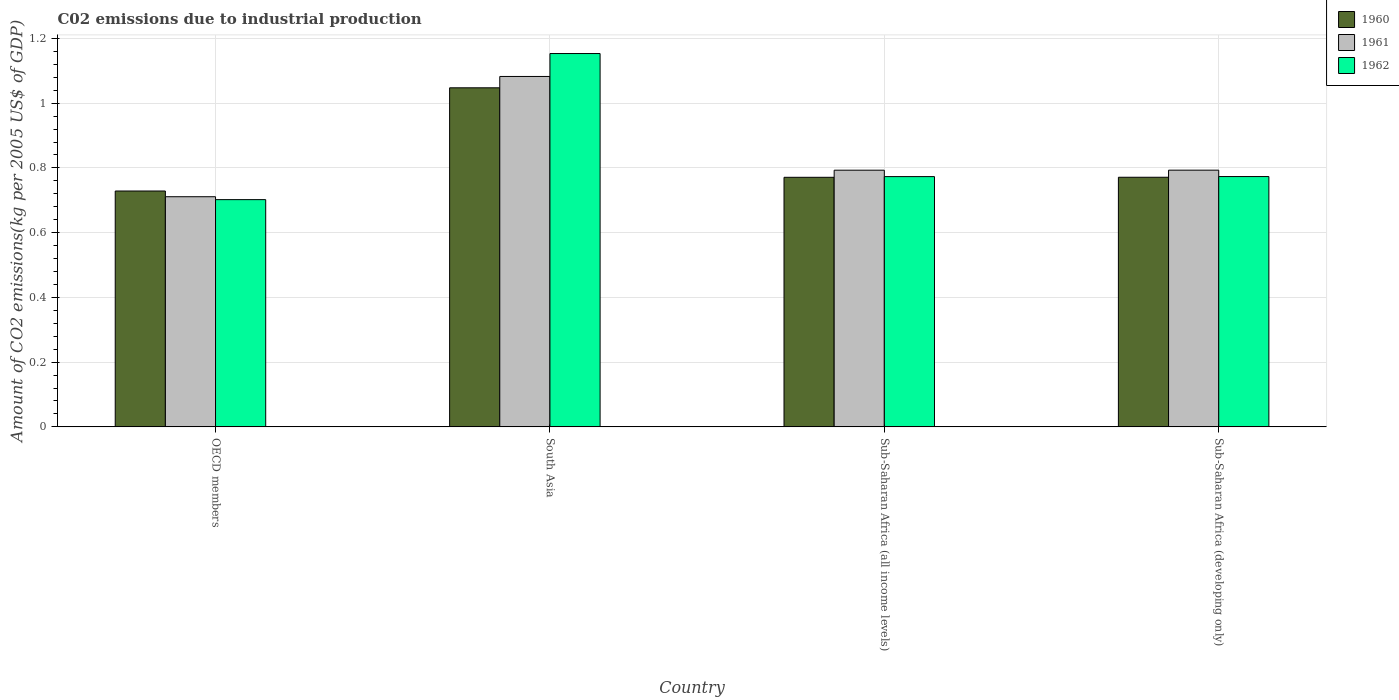How many groups of bars are there?
Your answer should be very brief. 4. Are the number of bars per tick equal to the number of legend labels?
Keep it short and to the point. Yes. How many bars are there on the 2nd tick from the left?
Ensure brevity in your answer.  3. In how many cases, is the number of bars for a given country not equal to the number of legend labels?
Ensure brevity in your answer.  0. What is the amount of CO2 emitted due to industrial production in 1962 in South Asia?
Offer a very short reply. 1.15. Across all countries, what is the maximum amount of CO2 emitted due to industrial production in 1961?
Keep it short and to the point. 1.08. Across all countries, what is the minimum amount of CO2 emitted due to industrial production in 1960?
Ensure brevity in your answer.  0.73. In which country was the amount of CO2 emitted due to industrial production in 1961 maximum?
Give a very brief answer. South Asia. In which country was the amount of CO2 emitted due to industrial production in 1962 minimum?
Offer a terse response. OECD members. What is the total amount of CO2 emitted due to industrial production in 1962 in the graph?
Provide a succinct answer. 3.4. What is the difference between the amount of CO2 emitted due to industrial production in 1961 in OECD members and that in Sub-Saharan Africa (developing only)?
Your answer should be compact. -0.08. What is the difference between the amount of CO2 emitted due to industrial production in 1961 in South Asia and the amount of CO2 emitted due to industrial production in 1962 in Sub-Saharan Africa (developing only)?
Your response must be concise. 0.31. What is the average amount of CO2 emitted due to industrial production in 1961 per country?
Your answer should be compact. 0.84. What is the difference between the amount of CO2 emitted due to industrial production of/in 1961 and amount of CO2 emitted due to industrial production of/in 1960 in South Asia?
Give a very brief answer. 0.04. In how many countries, is the amount of CO2 emitted due to industrial production in 1960 greater than 0.24000000000000002 kg?
Ensure brevity in your answer.  4. What is the ratio of the amount of CO2 emitted due to industrial production in 1960 in South Asia to that in Sub-Saharan Africa (developing only)?
Make the answer very short. 1.36. What is the difference between the highest and the second highest amount of CO2 emitted due to industrial production in 1961?
Provide a succinct answer. -0.29. What is the difference between the highest and the lowest amount of CO2 emitted due to industrial production in 1961?
Give a very brief answer. 0.37. Is the sum of the amount of CO2 emitted due to industrial production in 1962 in South Asia and Sub-Saharan Africa (all income levels) greater than the maximum amount of CO2 emitted due to industrial production in 1960 across all countries?
Provide a short and direct response. Yes. What does the 2nd bar from the right in Sub-Saharan Africa (developing only) represents?
Keep it short and to the point. 1961. Are all the bars in the graph horizontal?
Make the answer very short. No. How many countries are there in the graph?
Ensure brevity in your answer.  4. Does the graph contain any zero values?
Your response must be concise. No. Does the graph contain grids?
Make the answer very short. Yes. How many legend labels are there?
Your answer should be very brief. 3. What is the title of the graph?
Ensure brevity in your answer.  C02 emissions due to industrial production. What is the label or title of the Y-axis?
Your response must be concise. Amount of CO2 emissions(kg per 2005 US$ of GDP). What is the Amount of CO2 emissions(kg per 2005 US$ of GDP) of 1960 in OECD members?
Provide a succinct answer. 0.73. What is the Amount of CO2 emissions(kg per 2005 US$ of GDP) in 1961 in OECD members?
Your response must be concise. 0.71. What is the Amount of CO2 emissions(kg per 2005 US$ of GDP) of 1962 in OECD members?
Your answer should be very brief. 0.7. What is the Amount of CO2 emissions(kg per 2005 US$ of GDP) of 1960 in South Asia?
Offer a terse response. 1.05. What is the Amount of CO2 emissions(kg per 2005 US$ of GDP) in 1961 in South Asia?
Your answer should be very brief. 1.08. What is the Amount of CO2 emissions(kg per 2005 US$ of GDP) in 1962 in South Asia?
Your answer should be very brief. 1.15. What is the Amount of CO2 emissions(kg per 2005 US$ of GDP) of 1960 in Sub-Saharan Africa (all income levels)?
Offer a terse response. 0.77. What is the Amount of CO2 emissions(kg per 2005 US$ of GDP) in 1961 in Sub-Saharan Africa (all income levels)?
Give a very brief answer. 0.79. What is the Amount of CO2 emissions(kg per 2005 US$ of GDP) of 1962 in Sub-Saharan Africa (all income levels)?
Offer a terse response. 0.77. What is the Amount of CO2 emissions(kg per 2005 US$ of GDP) in 1960 in Sub-Saharan Africa (developing only)?
Make the answer very short. 0.77. What is the Amount of CO2 emissions(kg per 2005 US$ of GDP) of 1961 in Sub-Saharan Africa (developing only)?
Provide a short and direct response. 0.79. What is the Amount of CO2 emissions(kg per 2005 US$ of GDP) of 1962 in Sub-Saharan Africa (developing only)?
Provide a succinct answer. 0.77. Across all countries, what is the maximum Amount of CO2 emissions(kg per 2005 US$ of GDP) of 1960?
Your answer should be very brief. 1.05. Across all countries, what is the maximum Amount of CO2 emissions(kg per 2005 US$ of GDP) of 1961?
Keep it short and to the point. 1.08. Across all countries, what is the maximum Amount of CO2 emissions(kg per 2005 US$ of GDP) of 1962?
Provide a succinct answer. 1.15. Across all countries, what is the minimum Amount of CO2 emissions(kg per 2005 US$ of GDP) of 1960?
Ensure brevity in your answer.  0.73. Across all countries, what is the minimum Amount of CO2 emissions(kg per 2005 US$ of GDP) in 1961?
Give a very brief answer. 0.71. Across all countries, what is the minimum Amount of CO2 emissions(kg per 2005 US$ of GDP) in 1962?
Offer a very short reply. 0.7. What is the total Amount of CO2 emissions(kg per 2005 US$ of GDP) in 1960 in the graph?
Give a very brief answer. 3.32. What is the total Amount of CO2 emissions(kg per 2005 US$ of GDP) in 1961 in the graph?
Make the answer very short. 3.38. What is the total Amount of CO2 emissions(kg per 2005 US$ of GDP) in 1962 in the graph?
Your answer should be very brief. 3.4. What is the difference between the Amount of CO2 emissions(kg per 2005 US$ of GDP) in 1960 in OECD members and that in South Asia?
Offer a terse response. -0.32. What is the difference between the Amount of CO2 emissions(kg per 2005 US$ of GDP) of 1961 in OECD members and that in South Asia?
Ensure brevity in your answer.  -0.37. What is the difference between the Amount of CO2 emissions(kg per 2005 US$ of GDP) of 1962 in OECD members and that in South Asia?
Give a very brief answer. -0.45. What is the difference between the Amount of CO2 emissions(kg per 2005 US$ of GDP) in 1960 in OECD members and that in Sub-Saharan Africa (all income levels)?
Give a very brief answer. -0.04. What is the difference between the Amount of CO2 emissions(kg per 2005 US$ of GDP) of 1961 in OECD members and that in Sub-Saharan Africa (all income levels)?
Offer a very short reply. -0.08. What is the difference between the Amount of CO2 emissions(kg per 2005 US$ of GDP) in 1962 in OECD members and that in Sub-Saharan Africa (all income levels)?
Make the answer very short. -0.07. What is the difference between the Amount of CO2 emissions(kg per 2005 US$ of GDP) in 1960 in OECD members and that in Sub-Saharan Africa (developing only)?
Offer a terse response. -0.04. What is the difference between the Amount of CO2 emissions(kg per 2005 US$ of GDP) of 1961 in OECD members and that in Sub-Saharan Africa (developing only)?
Offer a very short reply. -0.08. What is the difference between the Amount of CO2 emissions(kg per 2005 US$ of GDP) of 1962 in OECD members and that in Sub-Saharan Africa (developing only)?
Your answer should be very brief. -0.07. What is the difference between the Amount of CO2 emissions(kg per 2005 US$ of GDP) in 1960 in South Asia and that in Sub-Saharan Africa (all income levels)?
Ensure brevity in your answer.  0.28. What is the difference between the Amount of CO2 emissions(kg per 2005 US$ of GDP) of 1961 in South Asia and that in Sub-Saharan Africa (all income levels)?
Your answer should be very brief. 0.29. What is the difference between the Amount of CO2 emissions(kg per 2005 US$ of GDP) in 1962 in South Asia and that in Sub-Saharan Africa (all income levels)?
Provide a short and direct response. 0.38. What is the difference between the Amount of CO2 emissions(kg per 2005 US$ of GDP) in 1960 in South Asia and that in Sub-Saharan Africa (developing only)?
Keep it short and to the point. 0.28. What is the difference between the Amount of CO2 emissions(kg per 2005 US$ of GDP) in 1961 in South Asia and that in Sub-Saharan Africa (developing only)?
Your answer should be very brief. 0.29. What is the difference between the Amount of CO2 emissions(kg per 2005 US$ of GDP) in 1962 in South Asia and that in Sub-Saharan Africa (developing only)?
Your answer should be compact. 0.38. What is the difference between the Amount of CO2 emissions(kg per 2005 US$ of GDP) of 1960 in Sub-Saharan Africa (all income levels) and that in Sub-Saharan Africa (developing only)?
Offer a very short reply. -0. What is the difference between the Amount of CO2 emissions(kg per 2005 US$ of GDP) of 1961 in Sub-Saharan Africa (all income levels) and that in Sub-Saharan Africa (developing only)?
Your response must be concise. -0. What is the difference between the Amount of CO2 emissions(kg per 2005 US$ of GDP) in 1962 in Sub-Saharan Africa (all income levels) and that in Sub-Saharan Africa (developing only)?
Make the answer very short. -0. What is the difference between the Amount of CO2 emissions(kg per 2005 US$ of GDP) in 1960 in OECD members and the Amount of CO2 emissions(kg per 2005 US$ of GDP) in 1961 in South Asia?
Ensure brevity in your answer.  -0.35. What is the difference between the Amount of CO2 emissions(kg per 2005 US$ of GDP) in 1960 in OECD members and the Amount of CO2 emissions(kg per 2005 US$ of GDP) in 1962 in South Asia?
Ensure brevity in your answer.  -0.42. What is the difference between the Amount of CO2 emissions(kg per 2005 US$ of GDP) of 1961 in OECD members and the Amount of CO2 emissions(kg per 2005 US$ of GDP) of 1962 in South Asia?
Your answer should be compact. -0.44. What is the difference between the Amount of CO2 emissions(kg per 2005 US$ of GDP) in 1960 in OECD members and the Amount of CO2 emissions(kg per 2005 US$ of GDP) in 1961 in Sub-Saharan Africa (all income levels)?
Offer a very short reply. -0.06. What is the difference between the Amount of CO2 emissions(kg per 2005 US$ of GDP) in 1960 in OECD members and the Amount of CO2 emissions(kg per 2005 US$ of GDP) in 1962 in Sub-Saharan Africa (all income levels)?
Your answer should be compact. -0.04. What is the difference between the Amount of CO2 emissions(kg per 2005 US$ of GDP) of 1961 in OECD members and the Amount of CO2 emissions(kg per 2005 US$ of GDP) of 1962 in Sub-Saharan Africa (all income levels)?
Keep it short and to the point. -0.06. What is the difference between the Amount of CO2 emissions(kg per 2005 US$ of GDP) of 1960 in OECD members and the Amount of CO2 emissions(kg per 2005 US$ of GDP) of 1961 in Sub-Saharan Africa (developing only)?
Keep it short and to the point. -0.06. What is the difference between the Amount of CO2 emissions(kg per 2005 US$ of GDP) in 1960 in OECD members and the Amount of CO2 emissions(kg per 2005 US$ of GDP) in 1962 in Sub-Saharan Africa (developing only)?
Your answer should be compact. -0.04. What is the difference between the Amount of CO2 emissions(kg per 2005 US$ of GDP) in 1961 in OECD members and the Amount of CO2 emissions(kg per 2005 US$ of GDP) in 1962 in Sub-Saharan Africa (developing only)?
Your response must be concise. -0.06. What is the difference between the Amount of CO2 emissions(kg per 2005 US$ of GDP) in 1960 in South Asia and the Amount of CO2 emissions(kg per 2005 US$ of GDP) in 1961 in Sub-Saharan Africa (all income levels)?
Give a very brief answer. 0.25. What is the difference between the Amount of CO2 emissions(kg per 2005 US$ of GDP) in 1960 in South Asia and the Amount of CO2 emissions(kg per 2005 US$ of GDP) in 1962 in Sub-Saharan Africa (all income levels)?
Give a very brief answer. 0.27. What is the difference between the Amount of CO2 emissions(kg per 2005 US$ of GDP) in 1961 in South Asia and the Amount of CO2 emissions(kg per 2005 US$ of GDP) in 1962 in Sub-Saharan Africa (all income levels)?
Provide a succinct answer. 0.31. What is the difference between the Amount of CO2 emissions(kg per 2005 US$ of GDP) of 1960 in South Asia and the Amount of CO2 emissions(kg per 2005 US$ of GDP) of 1961 in Sub-Saharan Africa (developing only)?
Provide a succinct answer. 0.25. What is the difference between the Amount of CO2 emissions(kg per 2005 US$ of GDP) in 1960 in South Asia and the Amount of CO2 emissions(kg per 2005 US$ of GDP) in 1962 in Sub-Saharan Africa (developing only)?
Offer a very short reply. 0.27. What is the difference between the Amount of CO2 emissions(kg per 2005 US$ of GDP) of 1961 in South Asia and the Amount of CO2 emissions(kg per 2005 US$ of GDP) of 1962 in Sub-Saharan Africa (developing only)?
Your answer should be compact. 0.31. What is the difference between the Amount of CO2 emissions(kg per 2005 US$ of GDP) of 1960 in Sub-Saharan Africa (all income levels) and the Amount of CO2 emissions(kg per 2005 US$ of GDP) of 1961 in Sub-Saharan Africa (developing only)?
Keep it short and to the point. -0.02. What is the difference between the Amount of CO2 emissions(kg per 2005 US$ of GDP) in 1960 in Sub-Saharan Africa (all income levels) and the Amount of CO2 emissions(kg per 2005 US$ of GDP) in 1962 in Sub-Saharan Africa (developing only)?
Provide a short and direct response. -0. What is the difference between the Amount of CO2 emissions(kg per 2005 US$ of GDP) in 1961 in Sub-Saharan Africa (all income levels) and the Amount of CO2 emissions(kg per 2005 US$ of GDP) in 1962 in Sub-Saharan Africa (developing only)?
Offer a terse response. 0.02. What is the average Amount of CO2 emissions(kg per 2005 US$ of GDP) in 1960 per country?
Ensure brevity in your answer.  0.83. What is the average Amount of CO2 emissions(kg per 2005 US$ of GDP) in 1961 per country?
Your response must be concise. 0.84. What is the average Amount of CO2 emissions(kg per 2005 US$ of GDP) in 1962 per country?
Provide a short and direct response. 0.85. What is the difference between the Amount of CO2 emissions(kg per 2005 US$ of GDP) in 1960 and Amount of CO2 emissions(kg per 2005 US$ of GDP) in 1961 in OECD members?
Give a very brief answer. 0.02. What is the difference between the Amount of CO2 emissions(kg per 2005 US$ of GDP) of 1960 and Amount of CO2 emissions(kg per 2005 US$ of GDP) of 1962 in OECD members?
Your response must be concise. 0.03. What is the difference between the Amount of CO2 emissions(kg per 2005 US$ of GDP) in 1961 and Amount of CO2 emissions(kg per 2005 US$ of GDP) in 1962 in OECD members?
Keep it short and to the point. 0.01. What is the difference between the Amount of CO2 emissions(kg per 2005 US$ of GDP) of 1960 and Amount of CO2 emissions(kg per 2005 US$ of GDP) of 1961 in South Asia?
Make the answer very short. -0.04. What is the difference between the Amount of CO2 emissions(kg per 2005 US$ of GDP) in 1960 and Amount of CO2 emissions(kg per 2005 US$ of GDP) in 1962 in South Asia?
Give a very brief answer. -0.11. What is the difference between the Amount of CO2 emissions(kg per 2005 US$ of GDP) in 1961 and Amount of CO2 emissions(kg per 2005 US$ of GDP) in 1962 in South Asia?
Your answer should be very brief. -0.07. What is the difference between the Amount of CO2 emissions(kg per 2005 US$ of GDP) in 1960 and Amount of CO2 emissions(kg per 2005 US$ of GDP) in 1961 in Sub-Saharan Africa (all income levels)?
Make the answer very short. -0.02. What is the difference between the Amount of CO2 emissions(kg per 2005 US$ of GDP) in 1960 and Amount of CO2 emissions(kg per 2005 US$ of GDP) in 1962 in Sub-Saharan Africa (all income levels)?
Ensure brevity in your answer.  -0. What is the difference between the Amount of CO2 emissions(kg per 2005 US$ of GDP) of 1961 and Amount of CO2 emissions(kg per 2005 US$ of GDP) of 1962 in Sub-Saharan Africa (all income levels)?
Provide a succinct answer. 0.02. What is the difference between the Amount of CO2 emissions(kg per 2005 US$ of GDP) of 1960 and Amount of CO2 emissions(kg per 2005 US$ of GDP) of 1961 in Sub-Saharan Africa (developing only)?
Offer a terse response. -0.02. What is the difference between the Amount of CO2 emissions(kg per 2005 US$ of GDP) of 1960 and Amount of CO2 emissions(kg per 2005 US$ of GDP) of 1962 in Sub-Saharan Africa (developing only)?
Your answer should be very brief. -0. What is the difference between the Amount of CO2 emissions(kg per 2005 US$ of GDP) of 1961 and Amount of CO2 emissions(kg per 2005 US$ of GDP) of 1962 in Sub-Saharan Africa (developing only)?
Keep it short and to the point. 0.02. What is the ratio of the Amount of CO2 emissions(kg per 2005 US$ of GDP) of 1960 in OECD members to that in South Asia?
Ensure brevity in your answer.  0.7. What is the ratio of the Amount of CO2 emissions(kg per 2005 US$ of GDP) of 1961 in OECD members to that in South Asia?
Offer a very short reply. 0.66. What is the ratio of the Amount of CO2 emissions(kg per 2005 US$ of GDP) in 1962 in OECD members to that in South Asia?
Your answer should be compact. 0.61. What is the ratio of the Amount of CO2 emissions(kg per 2005 US$ of GDP) of 1960 in OECD members to that in Sub-Saharan Africa (all income levels)?
Provide a succinct answer. 0.95. What is the ratio of the Amount of CO2 emissions(kg per 2005 US$ of GDP) of 1961 in OECD members to that in Sub-Saharan Africa (all income levels)?
Provide a succinct answer. 0.9. What is the ratio of the Amount of CO2 emissions(kg per 2005 US$ of GDP) in 1962 in OECD members to that in Sub-Saharan Africa (all income levels)?
Your answer should be compact. 0.91. What is the ratio of the Amount of CO2 emissions(kg per 2005 US$ of GDP) of 1960 in OECD members to that in Sub-Saharan Africa (developing only)?
Ensure brevity in your answer.  0.94. What is the ratio of the Amount of CO2 emissions(kg per 2005 US$ of GDP) in 1961 in OECD members to that in Sub-Saharan Africa (developing only)?
Provide a succinct answer. 0.9. What is the ratio of the Amount of CO2 emissions(kg per 2005 US$ of GDP) in 1962 in OECD members to that in Sub-Saharan Africa (developing only)?
Your answer should be very brief. 0.91. What is the ratio of the Amount of CO2 emissions(kg per 2005 US$ of GDP) of 1960 in South Asia to that in Sub-Saharan Africa (all income levels)?
Your answer should be very brief. 1.36. What is the ratio of the Amount of CO2 emissions(kg per 2005 US$ of GDP) of 1961 in South Asia to that in Sub-Saharan Africa (all income levels)?
Make the answer very short. 1.37. What is the ratio of the Amount of CO2 emissions(kg per 2005 US$ of GDP) in 1962 in South Asia to that in Sub-Saharan Africa (all income levels)?
Your answer should be compact. 1.49. What is the ratio of the Amount of CO2 emissions(kg per 2005 US$ of GDP) in 1960 in South Asia to that in Sub-Saharan Africa (developing only)?
Offer a terse response. 1.36. What is the ratio of the Amount of CO2 emissions(kg per 2005 US$ of GDP) in 1961 in South Asia to that in Sub-Saharan Africa (developing only)?
Provide a short and direct response. 1.36. What is the ratio of the Amount of CO2 emissions(kg per 2005 US$ of GDP) in 1962 in South Asia to that in Sub-Saharan Africa (developing only)?
Provide a succinct answer. 1.49. What is the ratio of the Amount of CO2 emissions(kg per 2005 US$ of GDP) in 1961 in Sub-Saharan Africa (all income levels) to that in Sub-Saharan Africa (developing only)?
Your response must be concise. 1. What is the ratio of the Amount of CO2 emissions(kg per 2005 US$ of GDP) in 1962 in Sub-Saharan Africa (all income levels) to that in Sub-Saharan Africa (developing only)?
Your answer should be compact. 1. What is the difference between the highest and the second highest Amount of CO2 emissions(kg per 2005 US$ of GDP) of 1960?
Your response must be concise. 0.28. What is the difference between the highest and the second highest Amount of CO2 emissions(kg per 2005 US$ of GDP) of 1961?
Provide a succinct answer. 0.29. What is the difference between the highest and the second highest Amount of CO2 emissions(kg per 2005 US$ of GDP) in 1962?
Give a very brief answer. 0.38. What is the difference between the highest and the lowest Amount of CO2 emissions(kg per 2005 US$ of GDP) of 1960?
Provide a short and direct response. 0.32. What is the difference between the highest and the lowest Amount of CO2 emissions(kg per 2005 US$ of GDP) of 1961?
Give a very brief answer. 0.37. What is the difference between the highest and the lowest Amount of CO2 emissions(kg per 2005 US$ of GDP) in 1962?
Your response must be concise. 0.45. 